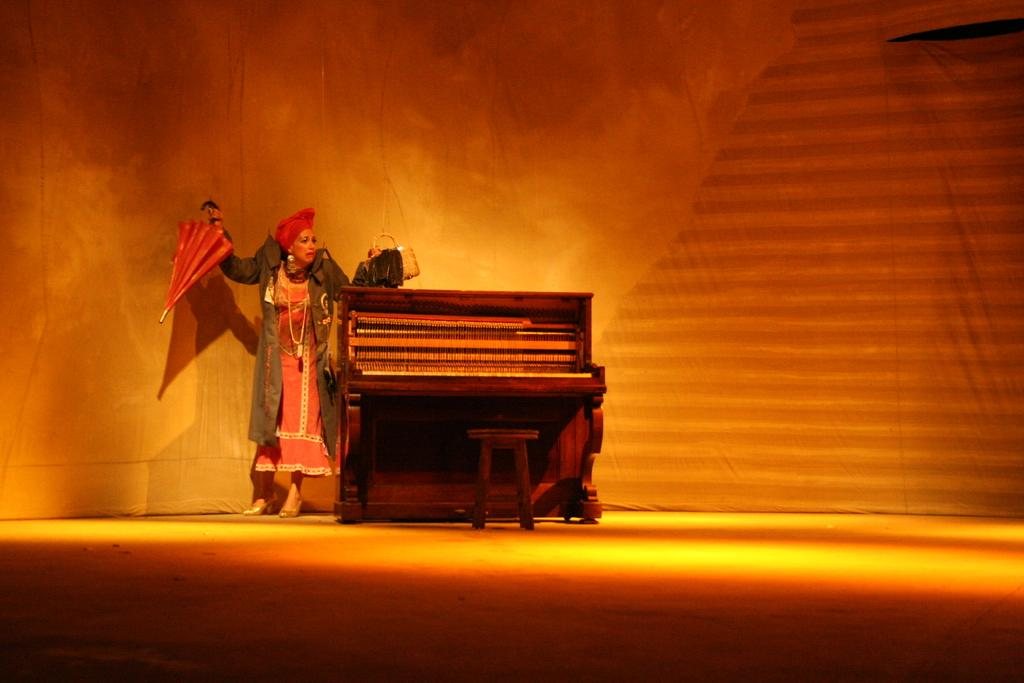What is the main object in the middle of the image? There is a piano in the middle of the image. Who is present on the left side of the image? There is a woman on the left side of the image. What is the woman wearing? The woman is wearing a black jacket. What items is the woman holding? The woman is holding an umbrella and a handbag. What might be the context of the scene? The scene may be a stage performance. What type of meat is being advertised on the piano in the image? There is no meat or advertisement present in the image; it features a piano and a woman. How many ants can be seen crawling on the woman's handbag in the image? There are no ants visible in the image; the woman is holding an umbrella and a handbag. 